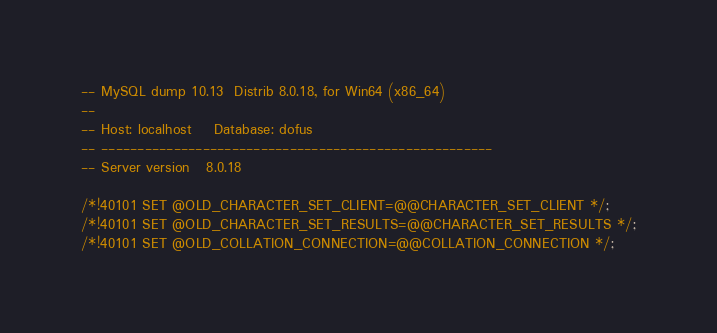<code> <loc_0><loc_0><loc_500><loc_500><_SQL_>-- MySQL dump 10.13  Distrib 8.0.18, for Win64 (x86_64)
--
-- Host: localhost    Database: dofus
-- ------------------------------------------------------
-- Server version	8.0.18

/*!40101 SET @OLD_CHARACTER_SET_CLIENT=@@CHARACTER_SET_CLIENT */;
/*!40101 SET @OLD_CHARACTER_SET_RESULTS=@@CHARACTER_SET_RESULTS */;
/*!40101 SET @OLD_COLLATION_CONNECTION=@@COLLATION_CONNECTION */;</code> 